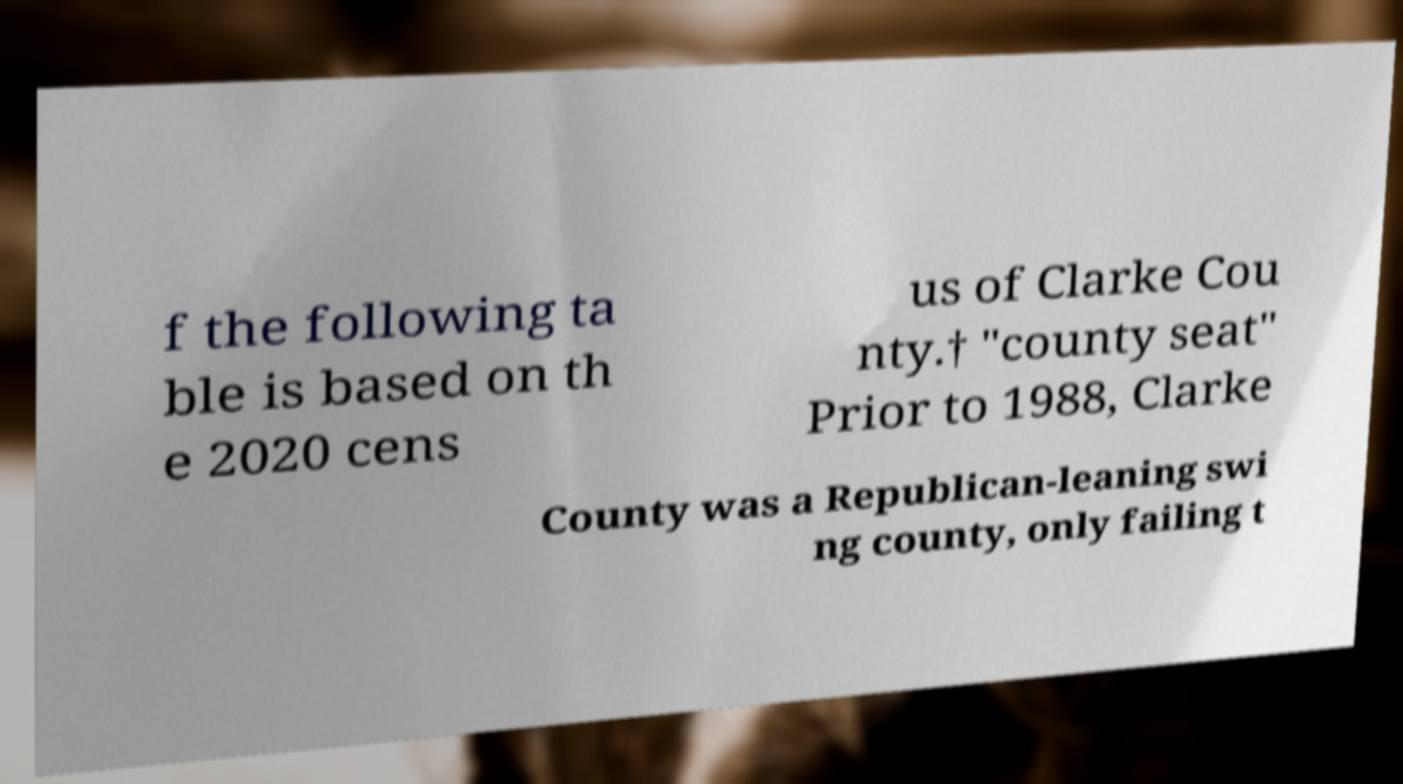I need the written content from this picture converted into text. Can you do that? f the following ta ble is based on th e 2020 cens us of Clarke Cou nty.† "county seat" Prior to 1988, Clarke County was a Republican-leaning swi ng county, only failing t 